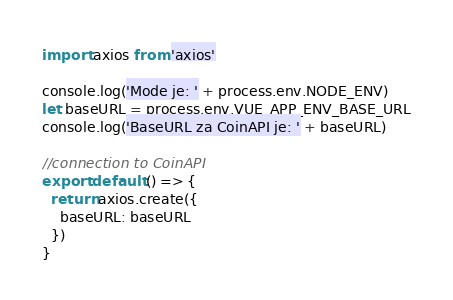<code> <loc_0><loc_0><loc_500><loc_500><_JavaScript_>import axios from 'axios'

console.log('Mode je: ' + process.env.NODE_ENV)
let baseURL = process.env.VUE_APP_ENV_BASE_URL
console.log('BaseURL za CoinAPI je: ' + baseURL)

//connection to CoinAPI
export default () => {
  return axios.create({
    baseURL: baseURL
  })
}</code> 